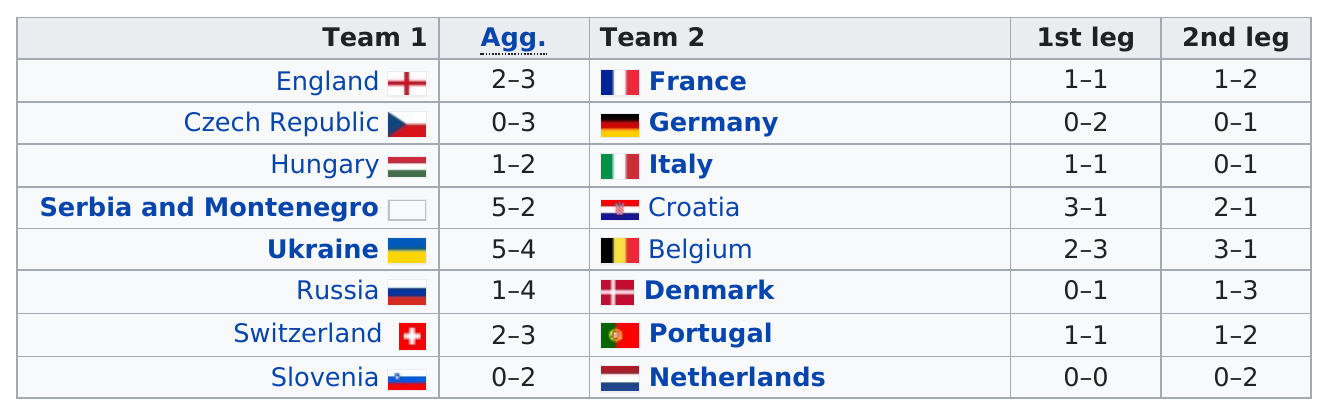Highlight a few significant elements in this photo. In the first leg of Belgium's match, they scored two goals. In the second leg, they also scored two goals, resulting in a total of four goals for the match. There were 16 teams that participated in the play-offs. Seventeen different countries participated in the event. There are eight countries in each team. Serbia and Montenegro had the highest overall score among all the countries. 